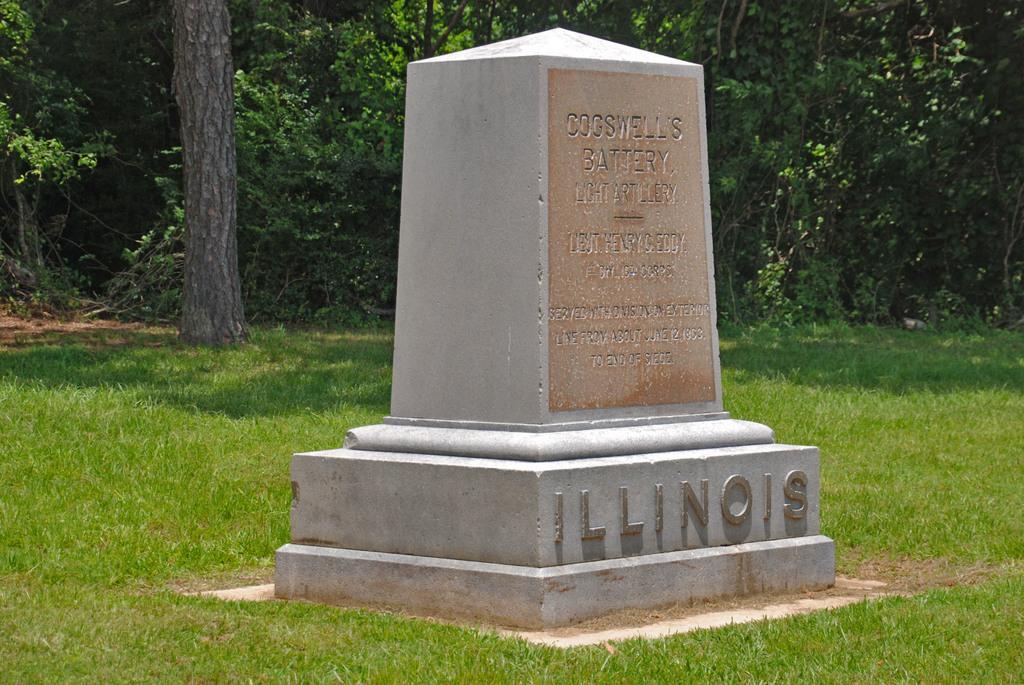How would you summarize this image in a sentence or two? In this image there is a memorial on the ground. There is text on the memorial. There is grass on the ground. In the background there are trees. 